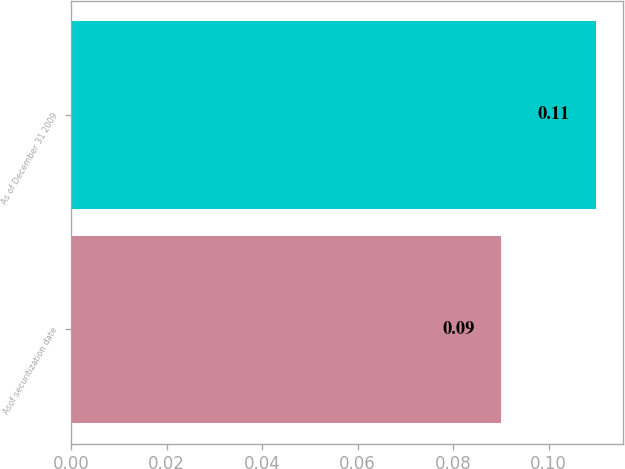Convert chart. <chart><loc_0><loc_0><loc_500><loc_500><bar_chart><fcel>Asof securitization date<fcel>As of December 31 2009<nl><fcel>0.09<fcel>0.11<nl></chart> 